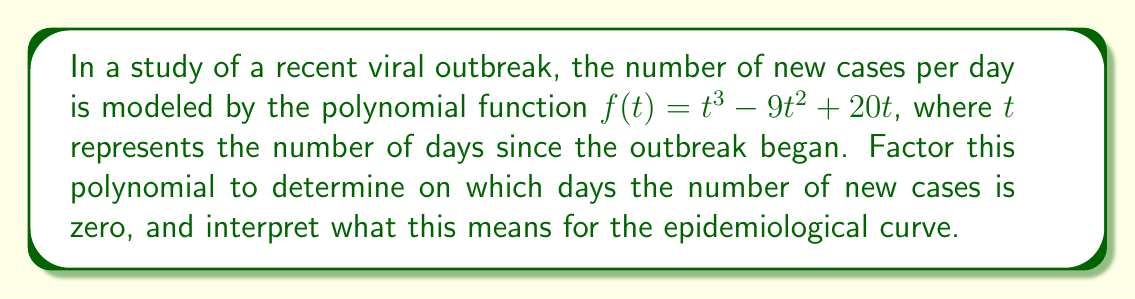Teach me how to tackle this problem. 1) First, let's factor the polynomial $f(t) = t^3 - 9t^2 + 20t$:

   $f(t) = t(t^2 - 9t + 20)$

2) We can further factor the quadratic term $(t^2 - 9t + 20)$:
   
   $f(t) = t(t - 4)(t - 5)$

3) The polynomial is now fully factored. The zeros of this function occur when any of these factors equal zero:

   $t = 0$, $t = 4$, or $t = 5$

4) Interpretation:
   - At $t = 0$: This represents the day the outbreak began. Naturally, there were zero new cases on this day.
   - At $t = 4$: Four days after the outbreak began, the number of new cases briefly dropped to zero.
   - At $t = 5$: Five days after the outbreak began, the number of new cases again dropped to zero.

5) For the epidemiological curve, this implies:
   - The outbreak started at day 0.
   - There was a brief period (days 4-5) where no new cases were reported.
   - After day 5, the number of new cases likely began to increase again, as the function becomes positive for $t > 5$.

This pattern could suggest an initial surge of cases, followed by a brief lull (possibly due to implemented control measures), and then potentially a resurgence of cases.
Answer: $t = 0, 4, 5$ days; initial surge, brief lull, potential resurgence 